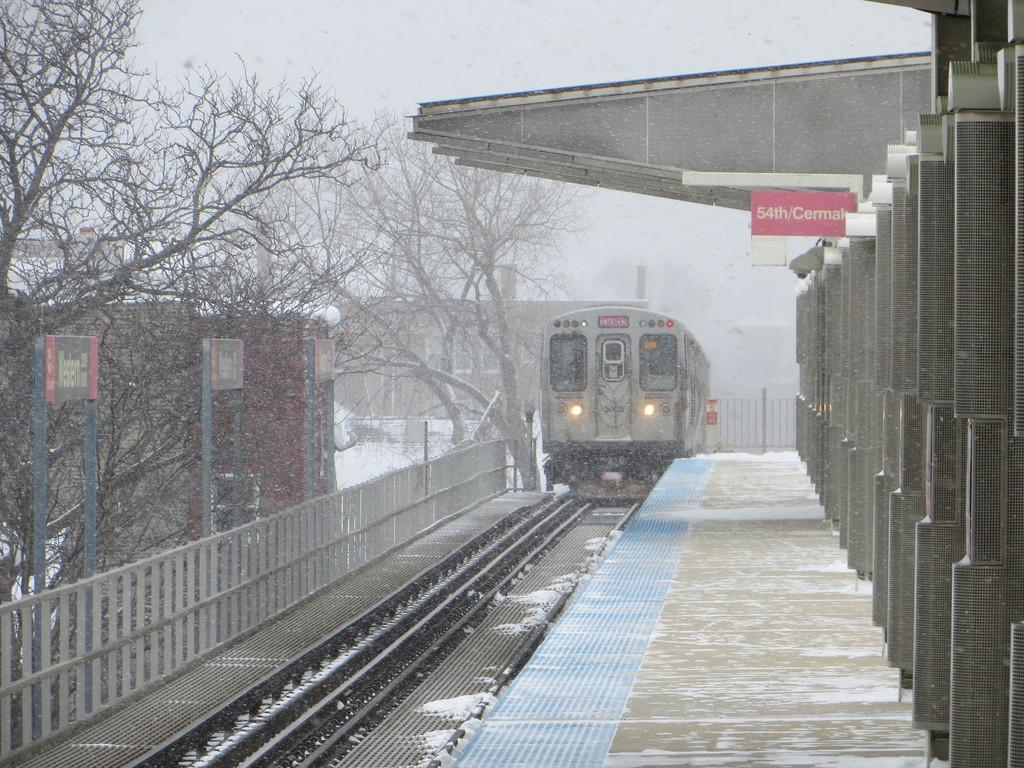<image>
Present a compact description of the photo's key features. A snowy station shows a red sign for 54th and Cermak. 